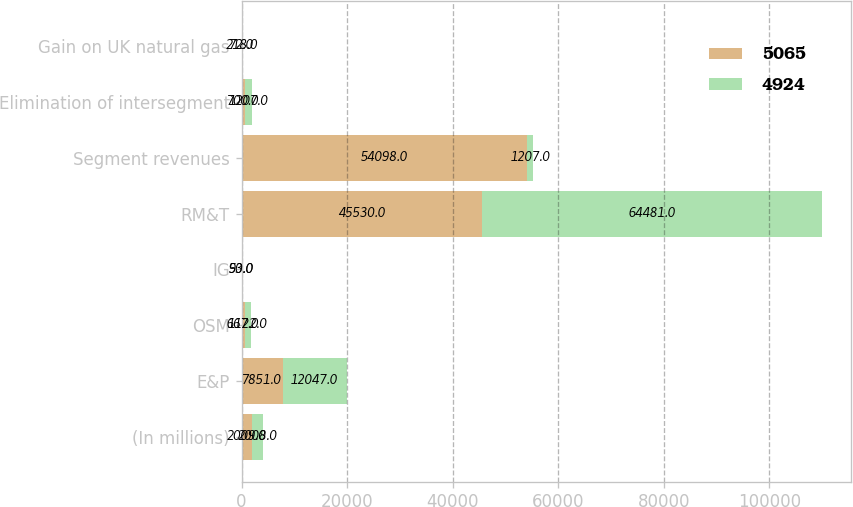Convert chart. <chart><loc_0><loc_0><loc_500><loc_500><stacked_bar_chart><ecel><fcel>(In millions)<fcel>E&P<fcel>OSM<fcel>IG<fcel>RM&T<fcel>Segment revenues<fcel>Elimination of intersegment<fcel>Gain on UK natural gas<nl><fcel>5065<fcel>2009<fcel>7851<fcel>667<fcel>50<fcel>45530<fcel>54098<fcel>700<fcel>72<nl><fcel>4924<fcel>2008<fcel>12047<fcel>1122<fcel>93<fcel>64481<fcel>1207<fcel>1207<fcel>218<nl></chart> 